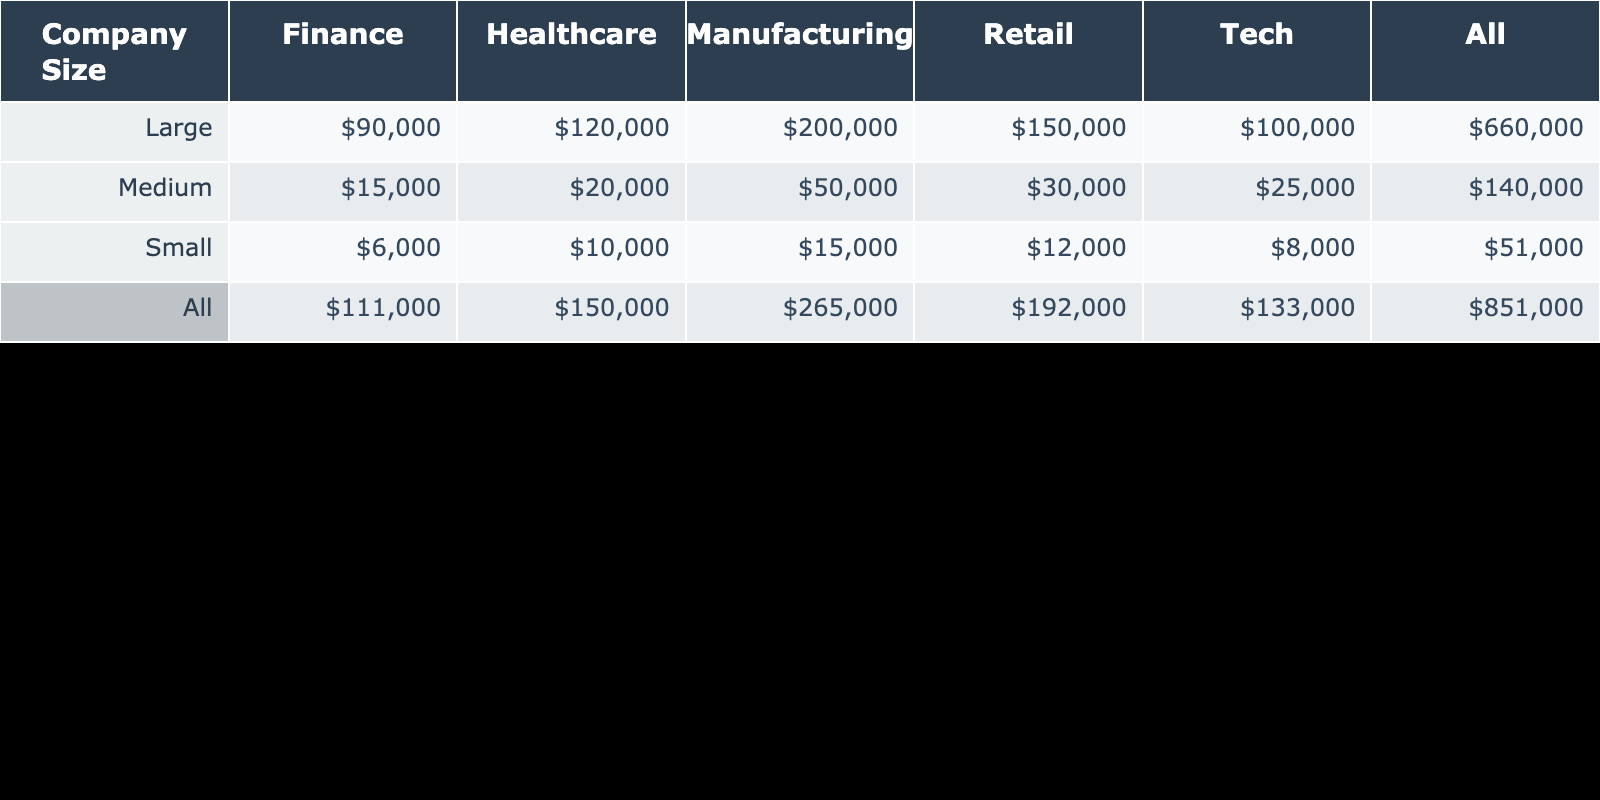What is the total community investment contribution from large companies in the healthcare industry? From the table, the contribution from large companies in healthcare is listed as 120,000 USD. Since there is only one entry for large healthcare contributions, the total is simply 120,000 USD.
Answer: 120,000 Which company size contributes the most to the retail industry? Looking at the table for retail contributions, large companies contributed 150,000 USD, which is higher than the contributions of medium (30,000 USD) and small (12,000 USD) companies. Therefore, large companies are the highest contributors to the retail industry.
Answer: Large What is the average community investment contribution from small companies across all industries? The contributions from small companies are 12,000 USD (Retail) + 8,000 USD (Tech) + 10,000 USD (Healthcare) + 15,000 USD (Manufacturing) + 6,000 USD (Finance) = 51,000 USD. There are 5 data points, so the average is 51,000 USD / 5 = 10,200 USD.
Answer: 10,200 Do medium companies contribute more to manufacturing than small companies? From the table, medium companies contributed 50,000 USD to manufacturing while small companies contributed 15,000 USD. Since 50,000 USD is greater than 15,000 USD, the answer is yes.
Answer: Yes What is the difference in community investment contributions between large companies in finance and small companies in the same industry? The contribution from large companies in finance is 90,000 USD, and from small companies is 6,000 USD. The difference is calculated as 90,000 USD - 6,000 USD = 84,000 USD.
Answer: 84,000 Overall, how much do medium companies contribute compared to large companies in the tech industry? Medium companies contribute 25,000 USD to tech while large companies contribute 100,000 USD. To compare, we note that 100,000 USD is greater than 25,000 USD. Therefore, large companies contribute more overall.
Answer: Larger Which industry received the highest average community investment contribution from all company sizes? The contributions by industry are: Retail (150,000 + 30,000 + 12,000), Tech (100,000 + 25,000 + 8,000), Healthcare (120,000 + 20,000 + 10,000), Manufacturing (200,000 + 50,000 + 15,000), and Finance (90,000 + 15,000 + 6,000). The total contributions by industry are then calculated and compared: Manufacturing (365,000 USD) has the highest total, so the average is 365,000 USD / 3 = 121,667 USD.
Answer: Manufacturing Does every industry have contributions from all company sizes? Referring to the table: Retail has all sizes, Tech has all sizes, Healthcare has all sizes, Manufacturing has all sizes, but Finance has no small companies listed. Hence, not every industry has contributions from all company sizes.
Answer: No 